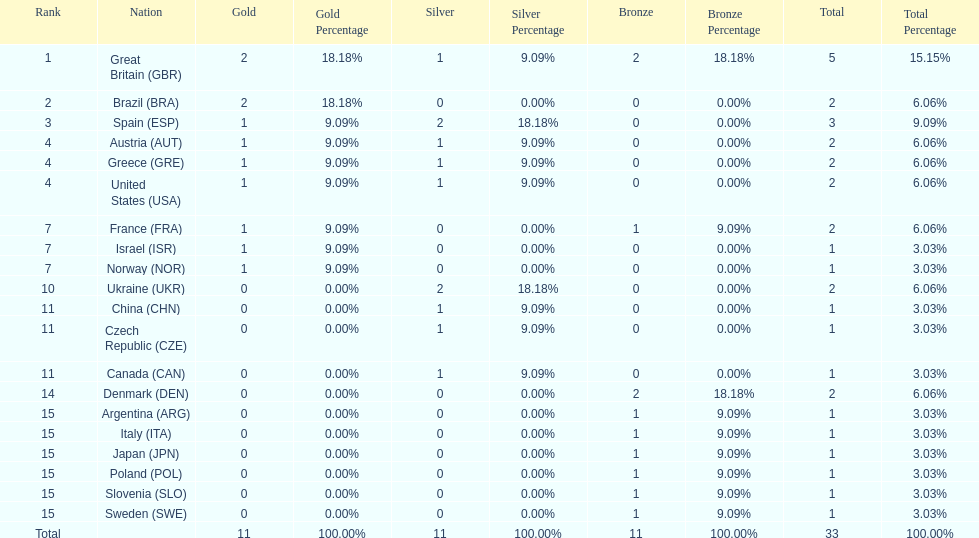How many countries won at least 2 medals in sailing? 9. 